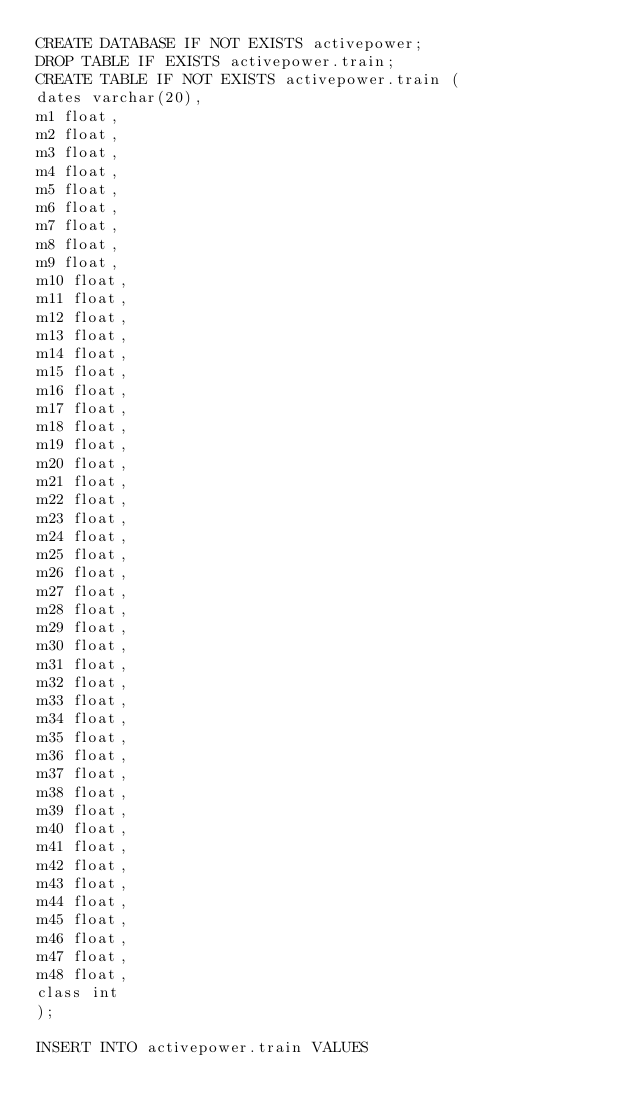Convert code to text. <code><loc_0><loc_0><loc_500><loc_500><_SQL_>CREATE DATABASE IF NOT EXISTS activepower;
DROP TABLE IF EXISTS activepower.train;
CREATE TABLE IF NOT EXISTS activepower.train (
dates varchar(20),
m1 float,
m2 float,
m3 float,
m4 float,
m5 float,
m6 float,
m7 float,
m8 float,
m9 float,
m10 float,
m11 float,
m12 float,
m13 float,
m14 float,
m15 float,
m16 float,
m17 float,
m18 float,
m19 float,
m20 float,
m21 float,
m22 float,
m23 float,
m24 float,
m25 float,
m26 float,
m27 float,
m28 float,
m29 float,
m30 float,
m31 float,
m32 float,
m33 float,
m34 float,
m35 float,
m36 float,
m37 float,
m38 float,
m39 float,
m40 float,
m41 float,
m42 float,
m43 float,
m44 float,
m45 float,
m46 float,
m47 float,
m48 float,
class int
);

INSERT INTO activepower.train VALUES</code> 